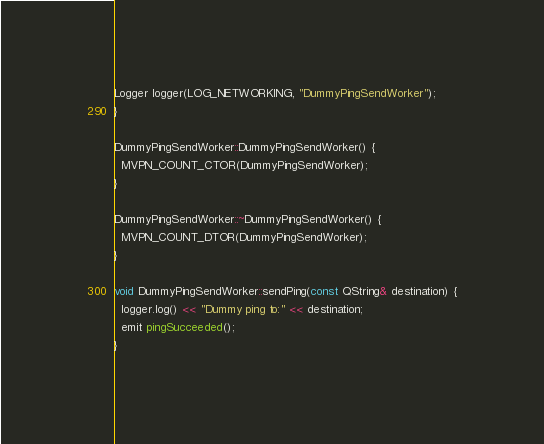<code> <loc_0><loc_0><loc_500><loc_500><_C++_>Logger logger(LOG_NETWORKING, "DummyPingSendWorker");
}

DummyPingSendWorker::DummyPingSendWorker() {
  MVPN_COUNT_CTOR(DummyPingSendWorker);
}

DummyPingSendWorker::~DummyPingSendWorker() {
  MVPN_COUNT_DTOR(DummyPingSendWorker);
}

void DummyPingSendWorker::sendPing(const QString& destination) {
  logger.log() << "Dummy ping to:" << destination;
  emit pingSucceeded();
}
</code> 